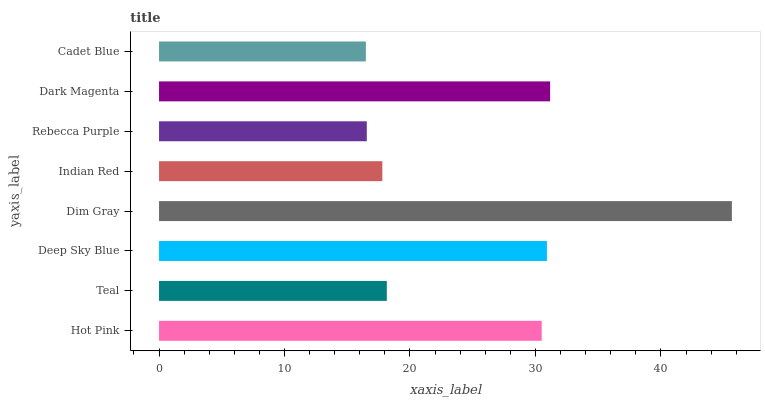Is Cadet Blue the minimum?
Answer yes or no. Yes. Is Dim Gray the maximum?
Answer yes or no. Yes. Is Teal the minimum?
Answer yes or no. No. Is Teal the maximum?
Answer yes or no. No. Is Hot Pink greater than Teal?
Answer yes or no. Yes. Is Teal less than Hot Pink?
Answer yes or no. Yes. Is Teal greater than Hot Pink?
Answer yes or no. No. Is Hot Pink less than Teal?
Answer yes or no. No. Is Hot Pink the high median?
Answer yes or no. Yes. Is Teal the low median?
Answer yes or no. Yes. Is Dark Magenta the high median?
Answer yes or no. No. Is Dim Gray the low median?
Answer yes or no. No. 